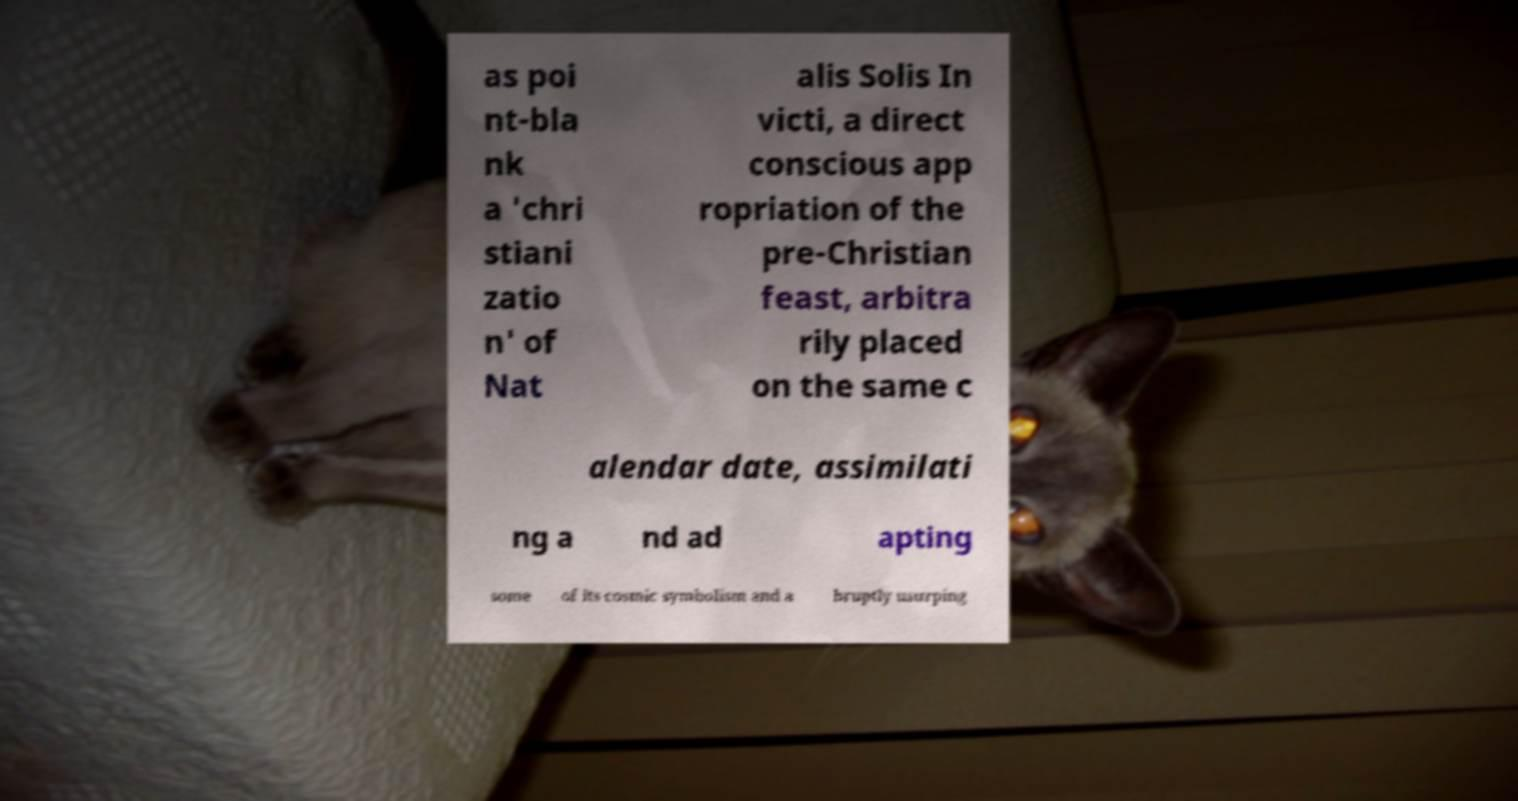Can you accurately transcribe the text from the provided image for me? as poi nt-bla nk a 'chri stiani zatio n' of Nat alis Solis In victi, a direct conscious app ropriation of the pre-Christian feast, arbitra rily placed on the same c alendar date, assimilati ng a nd ad apting some of its cosmic symbolism and a bruptly usurping 